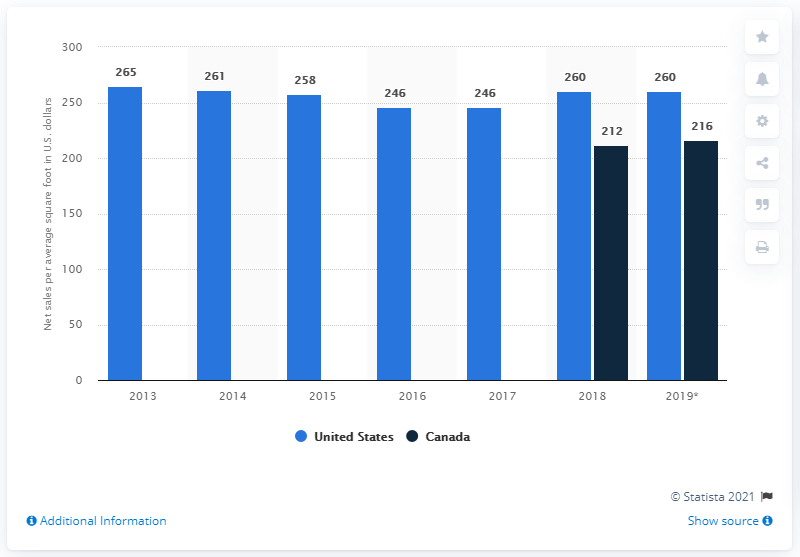Mention a couple of crucial points in this snapshot. In 2019, the net sales per average square foot of DSW in the United States was approximately $260. 